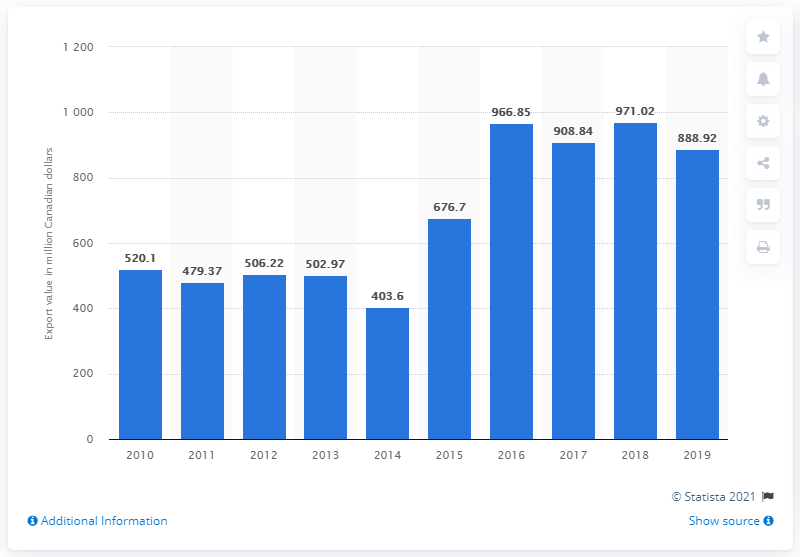Indicate a few pertinent items in this graphic. In 2019, Canada exported 888.92 metric tons of Atlantic salmon, which was worth an estimated CAD 1.3 billion in revenue. In the previous year, a total of 971.02 Atlantic salmon were exported from Canada. 